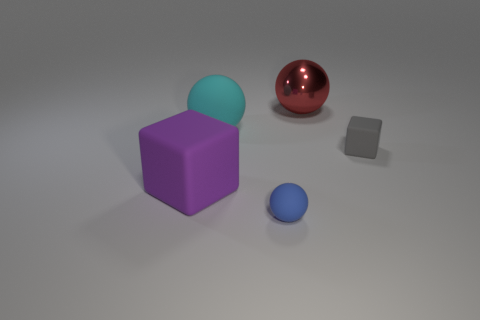What color is the sphere that is both behind the blue matte ball and on the right side of the big cyan object?
Ensure brevity in your answer.  Red. Is there anything else that is the same size as the purple object?
Offer a terse response. Yes. Are there more big spheres that are on the left side of the cyan sphere than blue rubber things?
Keep it short and to the point. No. What is the shape of the tiny rubber object right of the big object that is to the right of the rubber ball that is in front of the gray cube?
Your answer should be very brief. Cube. Is the size of the cube to the right of the purple matte block the same as the large purple rubber object?
Your answer should be compact. No. What shape is the large thing that is both behind the big cube and in front of the red thing?
Make the answer very short. Sphere. There is a tiny matte cube; is its color the same as the block that is left of the small blue sphere?
Offer a terse response. No. The rubber object that is to the left of the large matte sphere behind the matte thing to the right of the small blue rubber object is what color?
Offer a terse response. Purple. What color is the other large object that is the same shape as the gray object?
Your answer should be very brief. Purple. Are there an equal number of big matte objects that are right of the blue matte ball and tiny brown cubes?
Provide a short and direct response. Yes. 